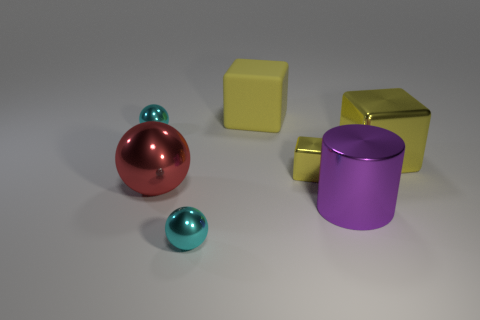Subtract all yellow blocks. How many were subtracted if there are1yellow blocks left? 2 Subtract all small cyan metallic balls. How many balls are left? 1 Subtract all red balls. How many balls are left? 2 Subtract all cylinders. How many objects are left? 6 Subtract 1 cylinders. How many cylinders are left? 0 Add 3 shiny cylinders. How many objects exist? 10 Subtract all cyan blocks. Subtract all purple cylinders. How many blocks are left? 3 Subtract all green spheres. How many red blocks are left? 0 Subtract all tiny yellow metallic things. Subtract all shiny cylinders. How many objects are left? 5 Add 3 big cylinders. How many big cylinders are left? 4 